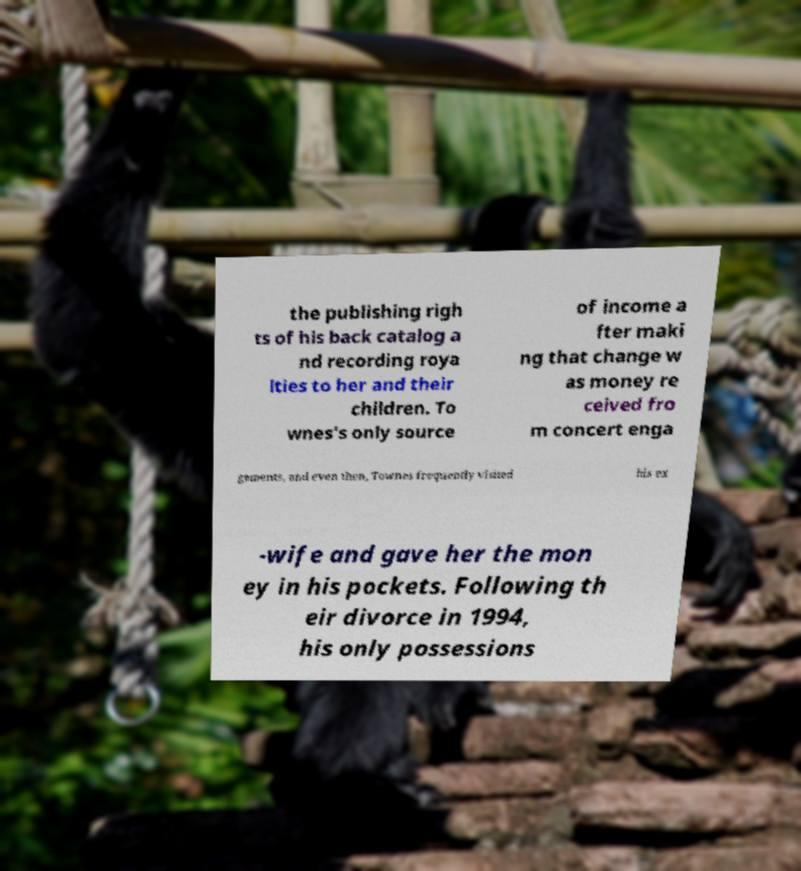There's text embedded in this image that I need extracted. Can you transcribe it verbatim? the publishing righ ts of his back catalog a nd recording roya lties to her and their children. To wnes's only source of income a fter maki ng that change w as money re ceived fro m concert enga gements, and even then, Townes frequently visited his ex -wife and gave her the mon ey in his pockets. Following th eir divorce in 1994, his only possessions 